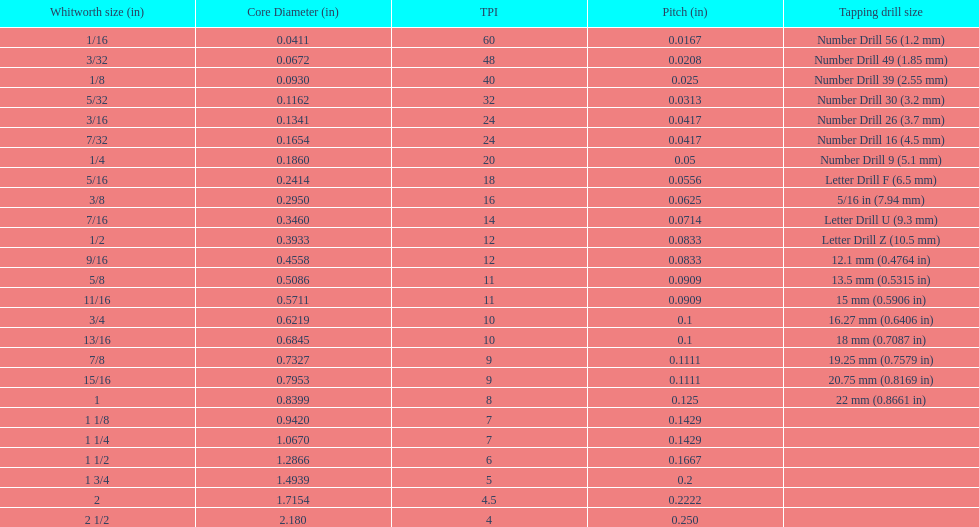How many more threads per inch does the 1/16th whitworth size have over the 1/8th whitworth size? 20. 